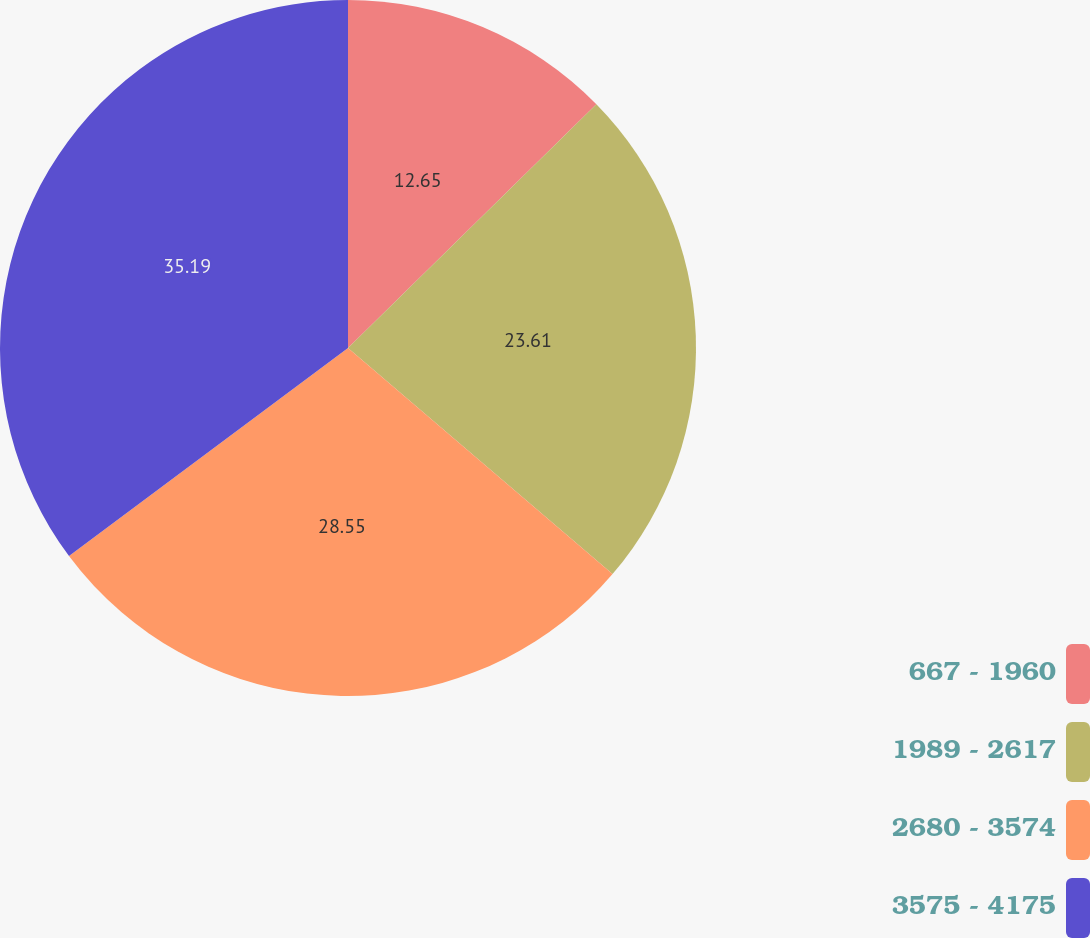Convert chart. <chart><loc_0><loc_0><loc_500><loc_500><pie_chart><fcel>667 - 1960<fcel>1989 - 2617<fcel>2680 - 3574<fcel>3575 - 4175<nl><fcel>12.65%<fcel>23.61%<fcel>28.55%<fcel>35.2%<nl></chart> 